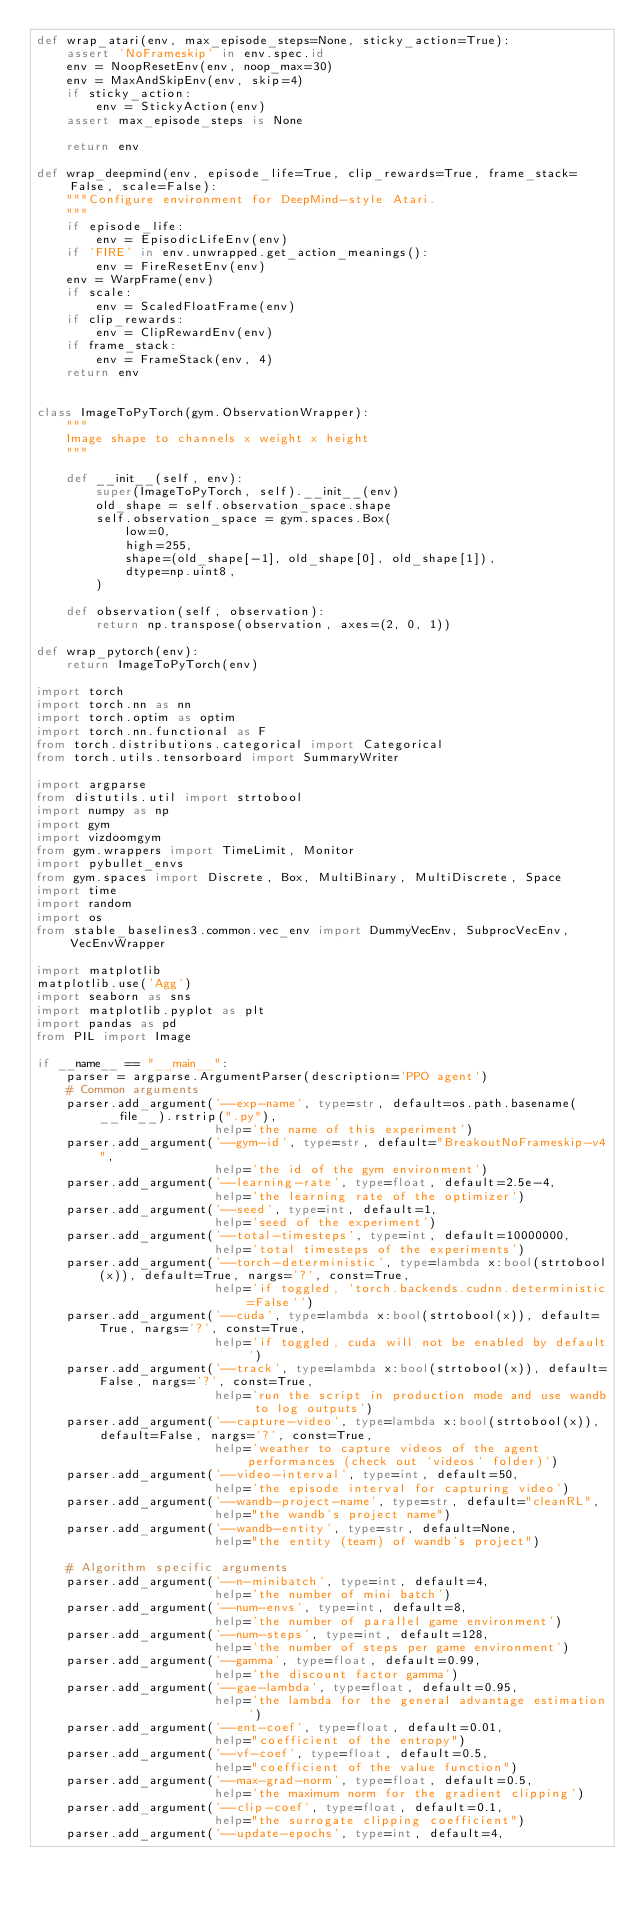<code> <loc_0><loc_0><loc_500><loc_500><_Python_>def wrap_atari(env, max_episode_steps=None, sticky_action=True):
    assert 'NoFrameskip' in env.spec.id
    env = NoopResetEnv(env, noop_max=30)
    env = MaxAndSkipEnv(env, skip=4)
    if sticky_action:
        env = StickyAction(env)
    assert max_episode_steps is None

    return env

def wrap_deepmind(env, episode_life=True, clip_rewards=True, frame_stack=False, scale=False):
    """Configure environment for DeepMind-style Atari.
    """
    if episode_life:
        env = EpisodicLifeEnv(env)
    if 'FIRE' in env.unwrapped.get_action_meanings():
        env = FireResetEnv(env)
    env = WarpFrame(env)
    if scale:
        env = ScaledFloatFrame(env)
    if clip_rewards:
        env = ClipRewardEnv(env)
    if frame_stack:
        env = FrameStack(env, 4)
    return env


class ImageToPyTorch(gym.ObservationWrapper):
    """
    Image shape to channels x weight x height
    """

    def __init__(self, env):
        super(ImageToPyTorch, self).__init__(env)
        old_shape = self.observation_space.shape
        self.observation_space = gym.spaces.Box(
            low=0,
            high=255,
            shape=(old_shape[-1], old_shape[0], old_shape[1]),
            dtype=np.uint8,
        )

    def observation(self, observation):
        return np.transpose(observation, axes=(2, 0, 1))

def wrap_pytorch(env):
    return ImageToPyTorch(env)

import torch
import torch.nn as nn
import torch.optim as optim
import torch.nn.functional as F
from torch.distributions.categorical import Categorical
from torch.utils.tensorboard import SummaryWriter

import argparse
from distutils.util import strtobool
import numpy as np
import gym
import vizdoomgym
from gym.wrappers import TimeLimit, Monitor
import pybullet_envs
from gym.spaces import Discrete, Box, MultiBinary, MultiDiscrete, Space
import time
import random
import os
from stable_baselines3.common.vec_env import DummyVecEnv, SubprocVecEnv, VecEnvWrapper

import matplotlib
matplotlib.use('Agg')
import seaborn as sns
import matplotlib.pyplot as plt
import pandas as pd
from PIL import Image

if __name__ == "__main__":
    parser = argparse.ArgumentParser(description='PPO agent')
    # Common arguments
    parser.add_argument('--exp-name', type=str, default=os.path.basename(__file__).rstrip(".py"),
                        help='the name of this experiment')
    parser.add_argument('--gym-id', type=str, default="BreakoutNoFrameskip-v4",
                        help='the id of the gym environment')
    parser.add_argument('--learning-rate', type=float, default=2.5e-4,
                        help='the learning rate of the optimizer')
    parser.add_argument('--seed', type=int, default=1,
                        help='seed of the experiment')
    parser.add_argument('--total-timesteps', type=int, default=10000000,
                        help='total timesteps of the experiments')
    parser.add_argument('--torch-deterministic', type=lambda x:bool(strtobool(x)), default=True, nargs='?', const=True,
                        help='if toggled, `torch.backends.cudnn.deterministic=False`')
    parser.add_argument('--cuda', type=lambda x:bool(strtobool(x)), default=True, nargs='?', const=True,
                        help='if toggled, cuda will not be enabled by default')
    parser.add_argument('--track', type=lambda x:bool(strtobool(x)), default=False, nargs='?', const=True,
                        help='run the script in production mode and use wandb to log outputs')
    parser.add_argument('--capture-video', type=lambda x:bool(strtobool(x)), default=False, nargs='?', const=True,
                        help='weather to capture videos of the agent performances (check out `videos` folder)')
    parser.add_argument('--video-interval', type=int, default=50,
                        help='the episode interval for capturing video')
    parser.add_argument('--wandb-project-name', type=str, default="cleanRL",
                        help="the wandb's project name")
    parser.add_argument('--wandb-entity', type=str, default=None,
                        help="the entity (team) of wandb's project")

    # Algorithm specific arguments
    parser.add_argument('--n-minibatch', type=int, default=4,
                        help='the number of mini batch')
    parser.add_argument('--num-envs', type=int, default=8,
                        help='the number of parallel game environment')
    parser.add_argument('--num-steps', type=int, default=128,
                        help='the number of steps per game environment')
    parser.add_argument('--gamma', type=float, default=0.99,
                        help='the discount factor gamma')
    parser.add_argument('--gae-lambda', type=float, default=0.95,
                        help='the lambda for the general advantage estimation')
    parser.add_argument('--ent-coef', type=float, default=0.01,
                        help="coefficient of the entropy")
    parser.add_argument('--vf-coef', type=float, default=0.5,
                        help="coefficient of the value function")
    parser.add_argument('--max-grad-norm', type=float, default=0.5,
                        help='the maximum norm for the gradient clipping')
    parser.add_argument('--clip-coef', type=float, default=0.1,
                        help="the surrogate clipping coefficient")
    parser.add_argument('--update-epochs', type=int, default=4,</code> 